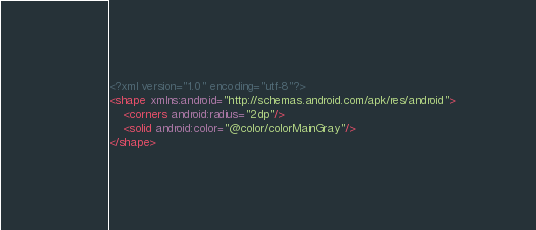Convert code to text. <code><loc_0><loc_0><loc_500><loc_500><_XML_><?xml version="1.0" encoding="utf-8"?>
<shape xmlns:android="http://schemas.android.com/apk/res/android">
    <corners android:radius="2dp"/>
    <solid android:color="@color/colorMainGray"/>
</shape></code> 